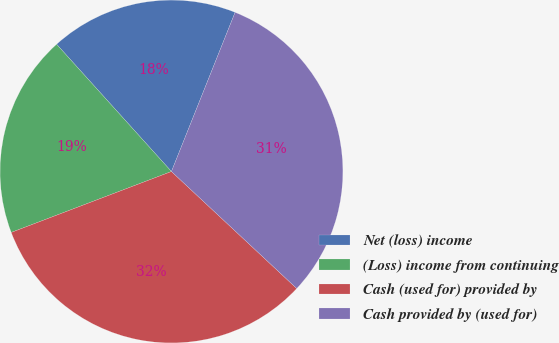Convert chart. <chart><loc_0><loc_0><loc_500><loc_500><pie_chart><fcel>Net (loss) income<fcel>(Loss) income from continuing<fcel>Cash (used for) provided by<fcel>Cash provided by (used for)<nl><fcel>17.74%<fcel>19.1%<fcel>32.26%<fcel>30.9%<nl></chart> 